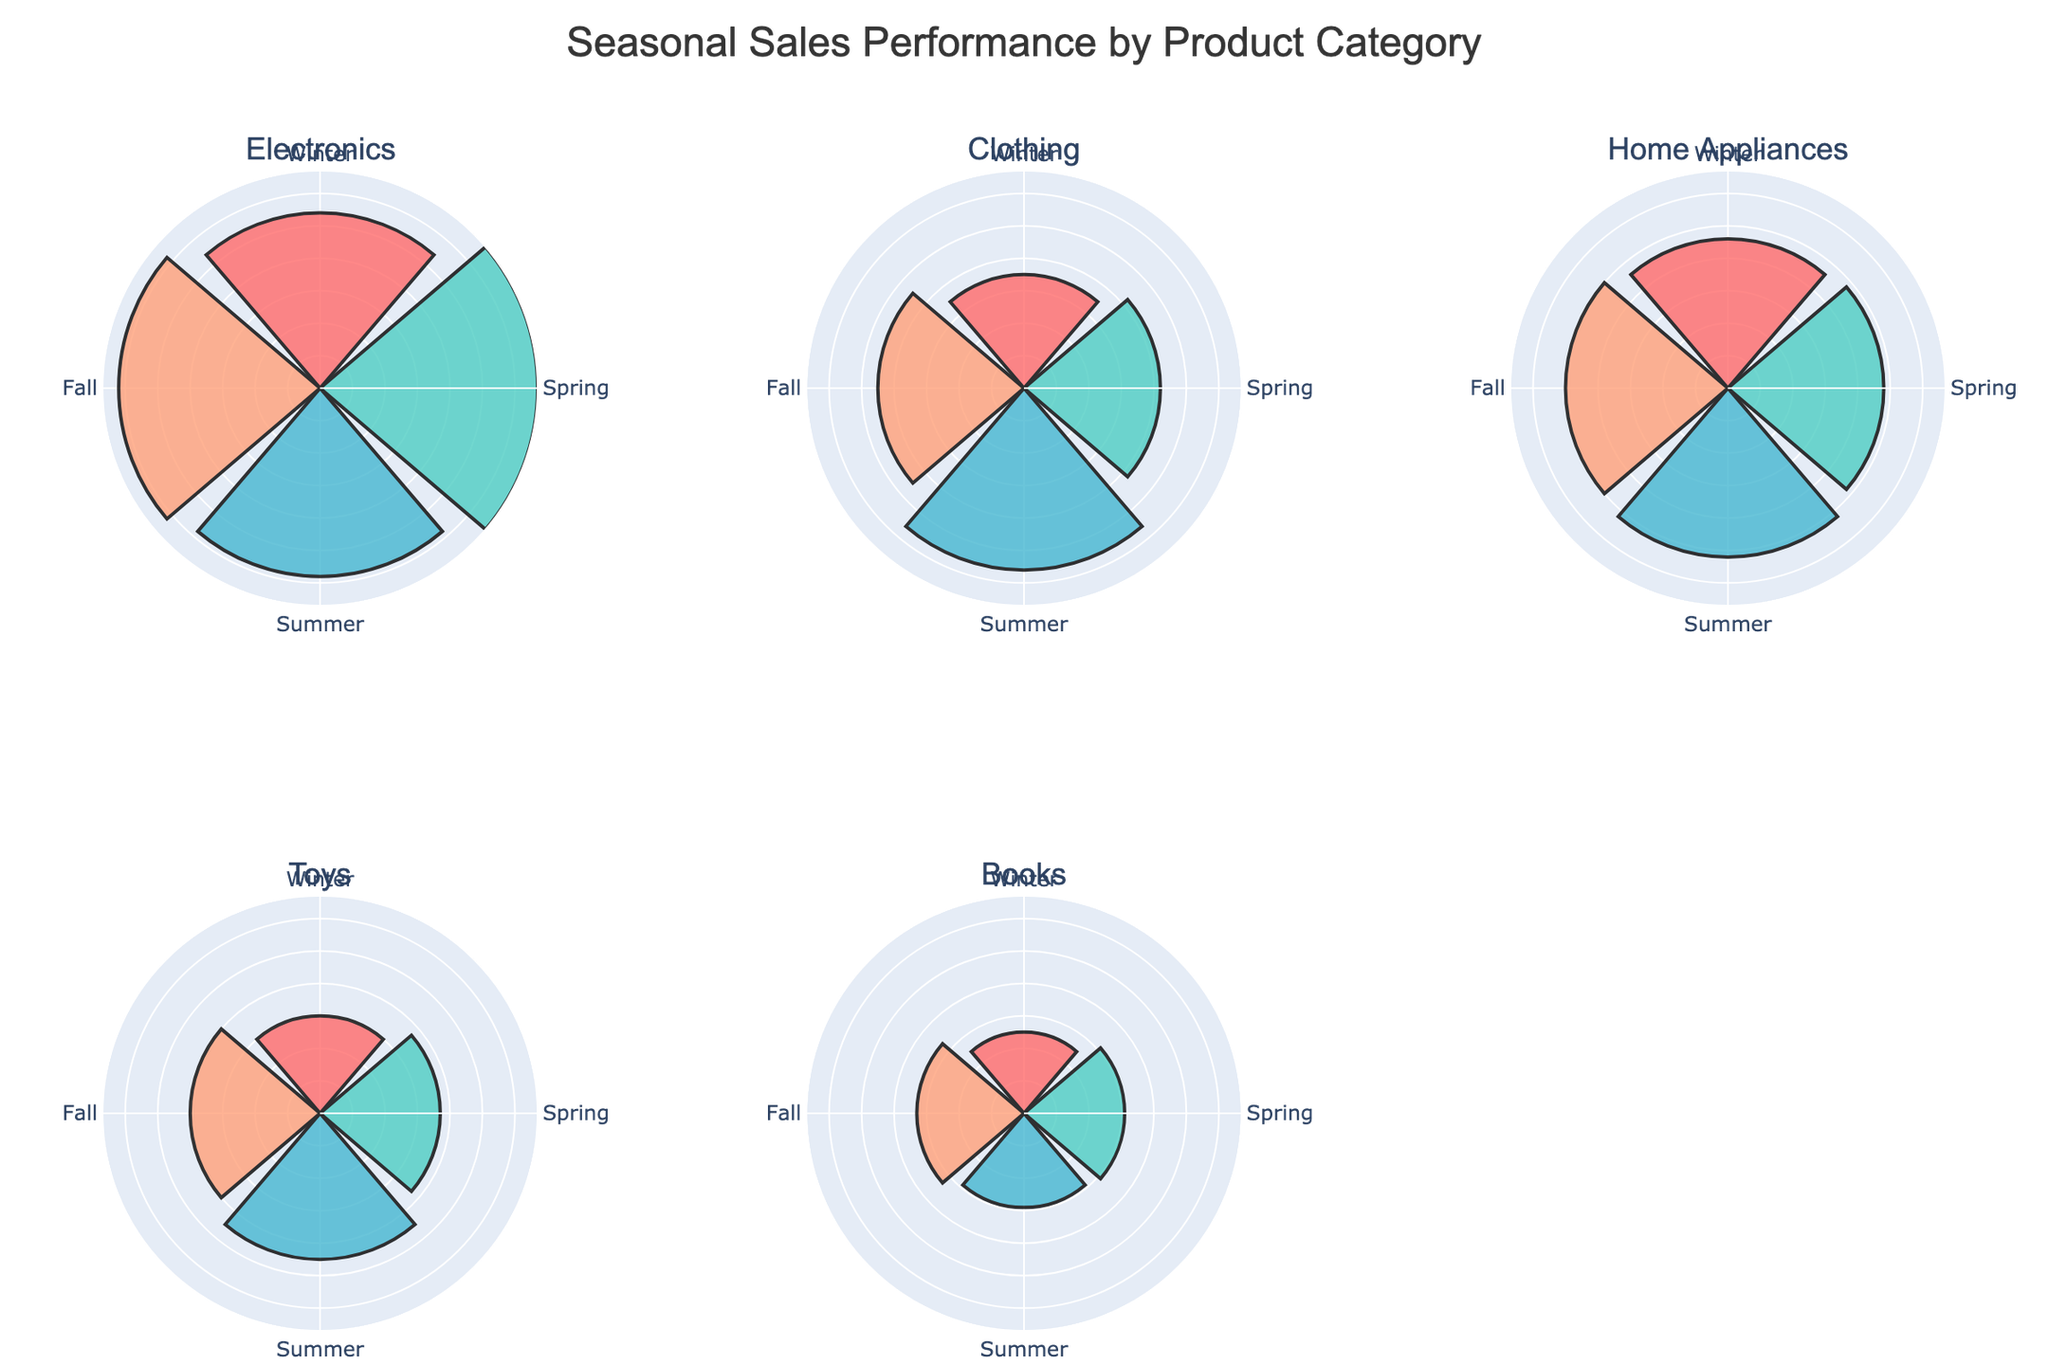What is the title of the figure? The title is usually displayed prominently at the top of the figure. In this case, it reads "Seasonal Sales Performance by Product Category".
Answer: Seasonal Sales Performance by Product Category Which season has the highest sales for Electronics? Examine the Electronics subplot and compare the lengths of the bars for each season. The bar for Spring is the longest.
Answer: Spring What is the total sales for Home Appliances? Sum the sales values for all seasons in the Home Appliances subplot: 46000 (Winter) + 48000 (Spring) + 52000 (Summer) + 50000 (Fall).
Answer: 196000 Is the sales performance for Toys higher in Summer or Winter? Compare the length of the bars for Summer and Winter in the Toys subplot. The Summer bar (45000) is longer than the Winter bar (30000).
Answer: Summer Which product category has the lowest sales in Winter? Check the subplots for the Winter season and compare the lengths of the bars for each category. Books has the lowest bar (25000).
Answer: Books How does the sales of Clothing in Summer compare to Fall? Compare the lengths of the bars for Summer and Fall in the Clothing subplot. The Summer bar (56000) is longer than the Fall bar (45000).
Answer: Summer is higher Which product category shows the most consistent sales across all seasons? Assess the uniformity of the bar lengths across seasons for each category. Home Appliances shows the most consistent sales range from 46000 to 52000.
Answer: Home Appliances What is the average sales for Books across all seasons? Sum the sales values for all seasons in the Books subplot: 25000 (Winter) + 31000 (Spring) + 29000 (Summer) + 33000 (Fall), which equals 118000. Divide by 4 (number of seasons).
Answer: 29500 Which season shows the highest sales performance across all categories? Compare the total lengths of the bars for each season across all subplots and seasons. Spring generally has the highest bars across all categories.
Answer: Spring In which season does Clothing outperform Electronics? Compare the Clothing and Electronics subplots for each season. In Summer, Clothing (56000) outperforms Electronics (58000).
Answer: No season 